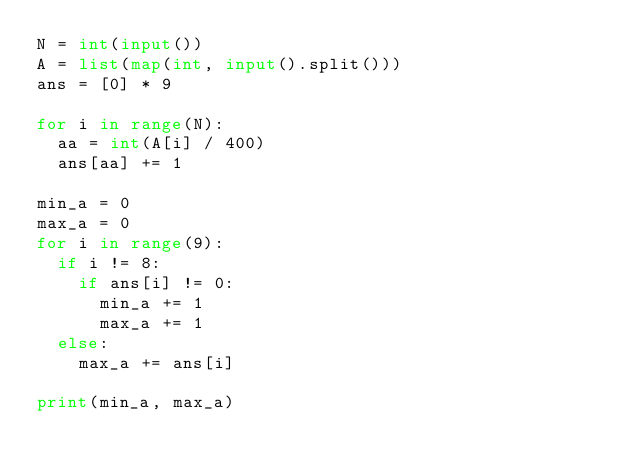Convert code to text. <code><loc_0><loc_0><loc_500><loc_500><_Python_>N = int(input())
A = list(map(int, input().split()))
ans = [0] * 9

for i in range(N):
  aa = int(A[i] / 400)
  ans[aa] += 1
  
min_a = 0
max_a = 0
for i in range(9):
  if i != 8:
    if ans[i] != 0:
      min_a += 1
      max_a += 1
  else:
    max_a += ans[i]
    
print(min_a, max_a)



</code> 